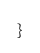<code> <loc_0><loc_0><loc_500><loc_500><_Rust_>}
</code> 